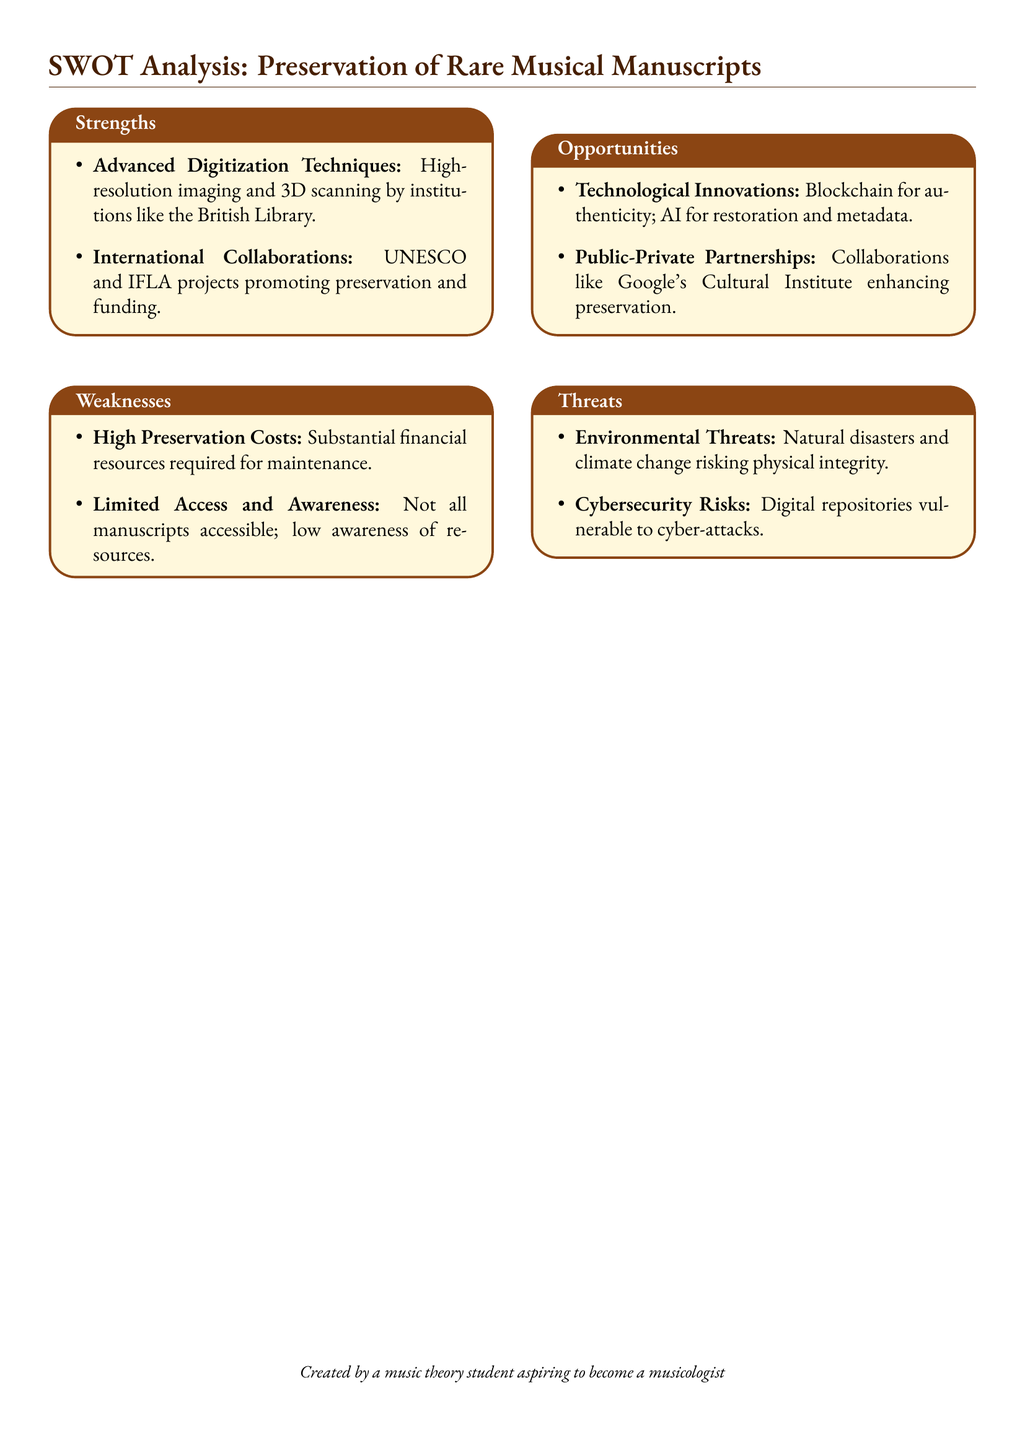What are two strengths mentioned in the document? The strengths include advanced digitization techniques and international collaborations.
Answer: Advanced Digitization Techniques, International Collaborations What are the weaknesses associated with the preservation of rare musical manuscripts? The weaknesses include high preservation costs and limited access and awareness.
Answer: High Preservation Costs, Limited Access and Awareness What technological innovations are proposed as opportunities? The opportunities include the use of blockchain for authenticity and AI for restoration.
Answer: Blockchain for authenticity, AI for restoration What threats are identified in relation to the preservation efforts? The threats encompass environmental threats and cybersecurity risks.
Answer: Environmental Threats, Cybersecurity Risks How many strengths are listed in the SWOT analysis? The SWOT analysis lists two strengths in the document.
Answer: Two What type of partnerships are mentioned as an opportunity? The opportunities mention public-private partnerships as a way to enhance preservation.
Answer: Public-Private Partnerships Which institution is mentioned for high-resolution imaging and 3D scanning? The British Library is cited for advanced digitization techniques.
Answer: British Library 